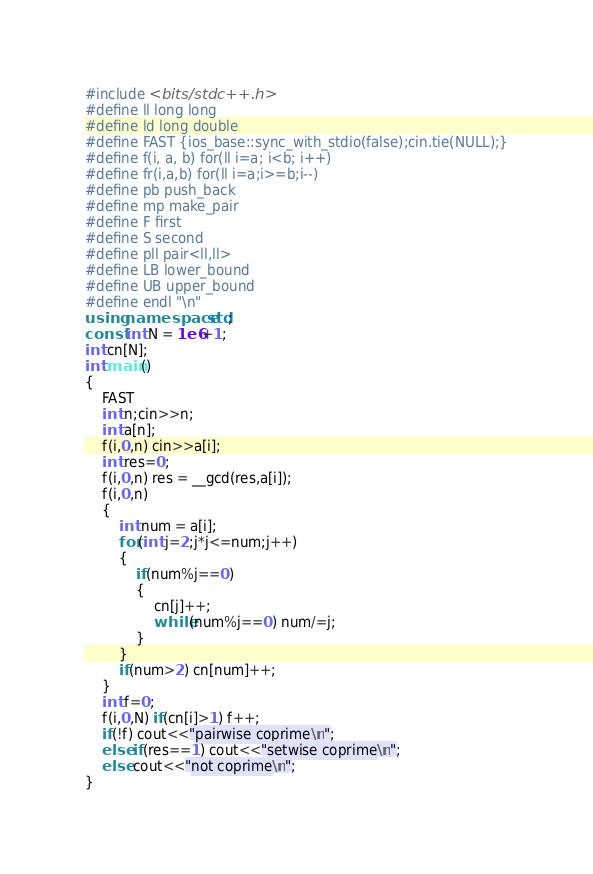Convert code to text. <code><loc_0><loc_0><loc_500><loc_500><_C++_>#include <bits/stdc++.h>
#define ll long long
#define ld long double
#define FAST {ios_base::sync_with_stdio(false);cin.tie(NULL);}
#define f(i, a, b) for(ll i=a; i<b; i++)
#define fr(i,a,b) for(ll i=a;i>=b;i--)
#define pb push_back
#define mp make_pair
#define F first
#define S second
#define pll pair<ll,ll>
#define LB lower_bound
#define UB upper_bound
#define endl "\n"
using namespace std;
const int N = 1e6+1;
int cn[N];
int main()
{
    FAST
    int n;cin>>n;
    int a[n];
    f(i,0,n) cin>>a[i];
    int res=0;
    f(i,0,n) res = __gcd(res,a[i]);
    f(i,0,n)
    {
        int num = a[i];
        for(int j=2;j*j<=num;j++)
        {
            if(num%j==0)
            {
                cn[j]++;
                while(num%j==0) num/=j;
            }
        }
        if(num>2) cn[num]++;
    }
    int f=0;
    f(i,0,N) if(cn[i]>1) f++;
    if(!f) cout<<"pairwise coprime\n";
    else if(res==1) cout<<"setwise coprime\n";
    else cout<<"not coprime\n";
}
</code> 